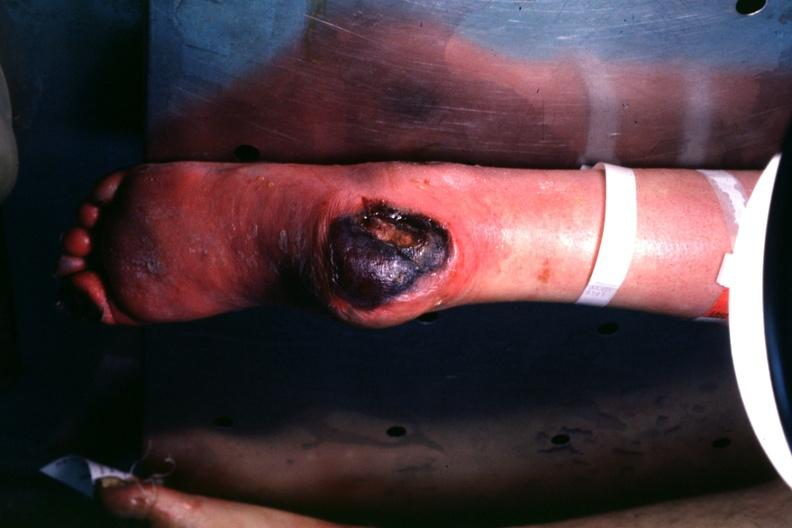what is present?
Answer the question using a single word or phrase. Heel ulcer 